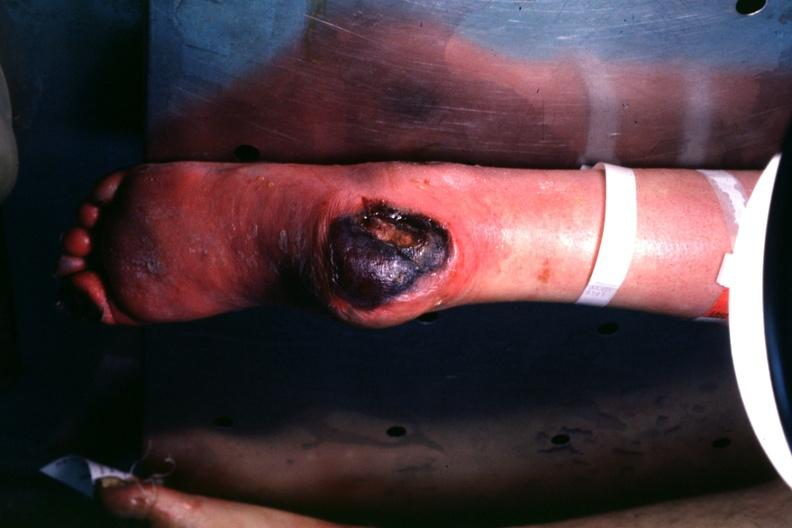what is present?
Answer the question using a single word or phrase. Heel ulcer 